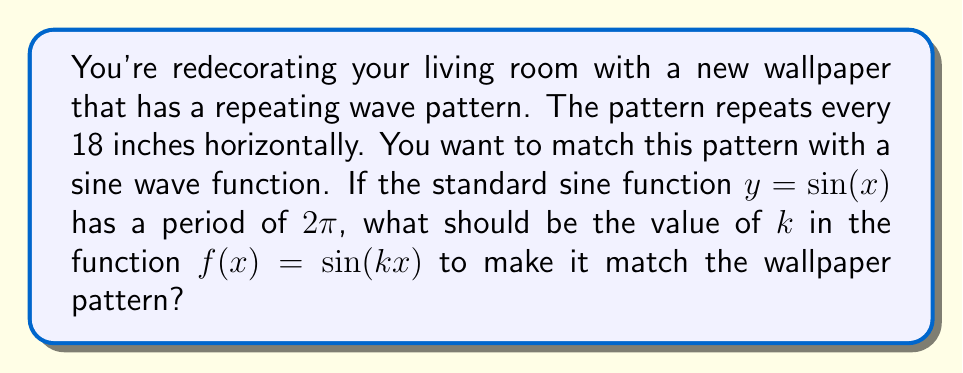Can you answer this question? Let's approach this step-by-step:

1) The standard sine function $y = \sin(x)$ has a period of $2\pi$.

2) The general form of a horizontally stretched sine function is $f(x) = \sin(kx)$, where $k$ is the stretch factor.

3) The period of $f(x) = \sin(kx)$ is $\frac{2\pi}{|k|}$.

4) We want this period to match the wallpaper pattern, which repeats every 18 inches.

5) So, we can set up the equation:

   $$\frac{2\pi}{|k|} = 18$$

6) Solving for $k$:

   $$|k| = \frac{2\pi}{18}$$

7) Simplifying:

   $$|k| = \frac{\pi}{9}$$

8) Since we're stretching the function horizontally (making the period longer), $k$ should be positive and less than 1. Therefore:

   $$k = \frac{\pi}{9}$$
Answer: $\frac{\pi}{9}$ 